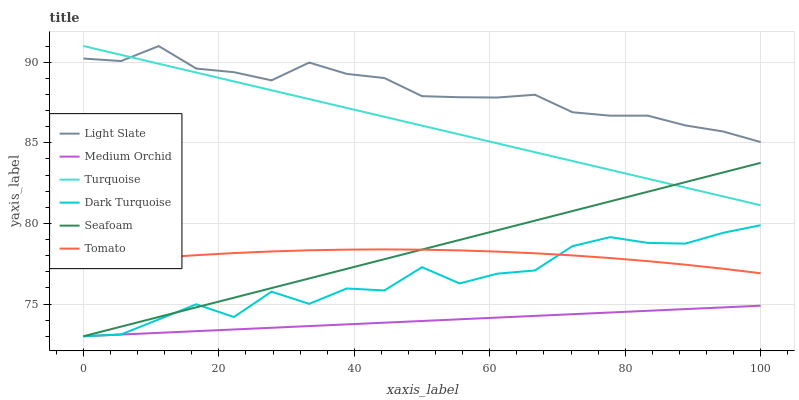Does Medium Orchid have the minimum area under the curve?
Answer yes or no. Yes. Does Light Slate have the maximum area under the curve?
Answer yes or no. Yes. Does Turquoise have the minimum area under the curve?
Answer yes or no. No. Does Turquoise have the maximum area under the curve?
Answer yes or no. No. Is Seafoam the smoothest?
Answer yes or no. Yes. Is Dark Turquoise the roughest?
Answer yes or no. Yes. Is Turquoise the smoothest?
Answer yes or no. No. Is Turquoise the roughest?
Answer yes or no. No. Does Turquoise have the lowest value?
Answer yes or no. No. Does Turquoise have the highest value?
Answer yes or no. Yes. Does Light Slate have the highest value?
Answer yes or no. No. Is Seafoam less than Light Slate?
Answer yes or no. Yes. Is Light Slate greater than Medium Orchid?
Answer yes or no. Yes. Does Seafoam intersect Turquoise?
Answer yes or no. Yes. Is Seafoam less than Turquoise?
Answer yes or no. No. Is Seafoam greater than Turquoise?
Answer yes or no. No. Does Seafoam intersect Light Slate?
Answer yes or no. No. 